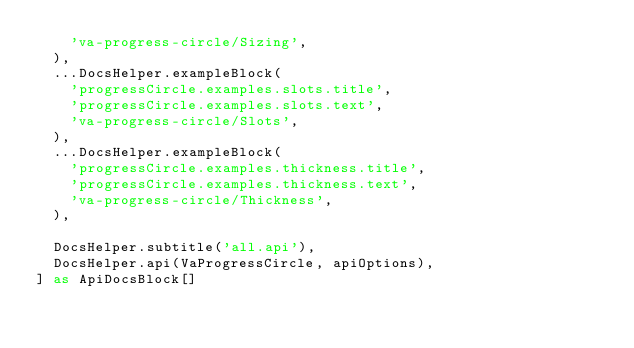<code> <loc_0><loc_0><loc_500><loc_500><_TypeScript_>    'va-progress-circle/Sizing',
  ),
  ...DocsHelper.exampleBlock(
    'progressCircle.examples.slots.title',
    'progressCircle.examples.slots.text',
    'va-progress-circle/Slots',
  ),
  ...DocsHelper.exampleBlock(
    'progressCircle.examples.thickness.title',
    'progressCircle.examples.thickness.text',
    'va-progress-circle/Thickness',
  ),

  DocsHelper.subtitle('all.api'),
  DocsHelper.api(VaProgressCircle, apiOptions),
] as ApiDocsBlock[]
</code> 